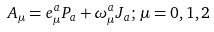Convert formula to latex. <formula><loc_0><loc_0><loc_500><loc_500>A _ { \mu } = e ^ { a } _ { \mu } P _ { a } + \omega ^ { a } _ { \mu } J _ { a } ; \, \mu = 0 , 1 , 2</formula> 